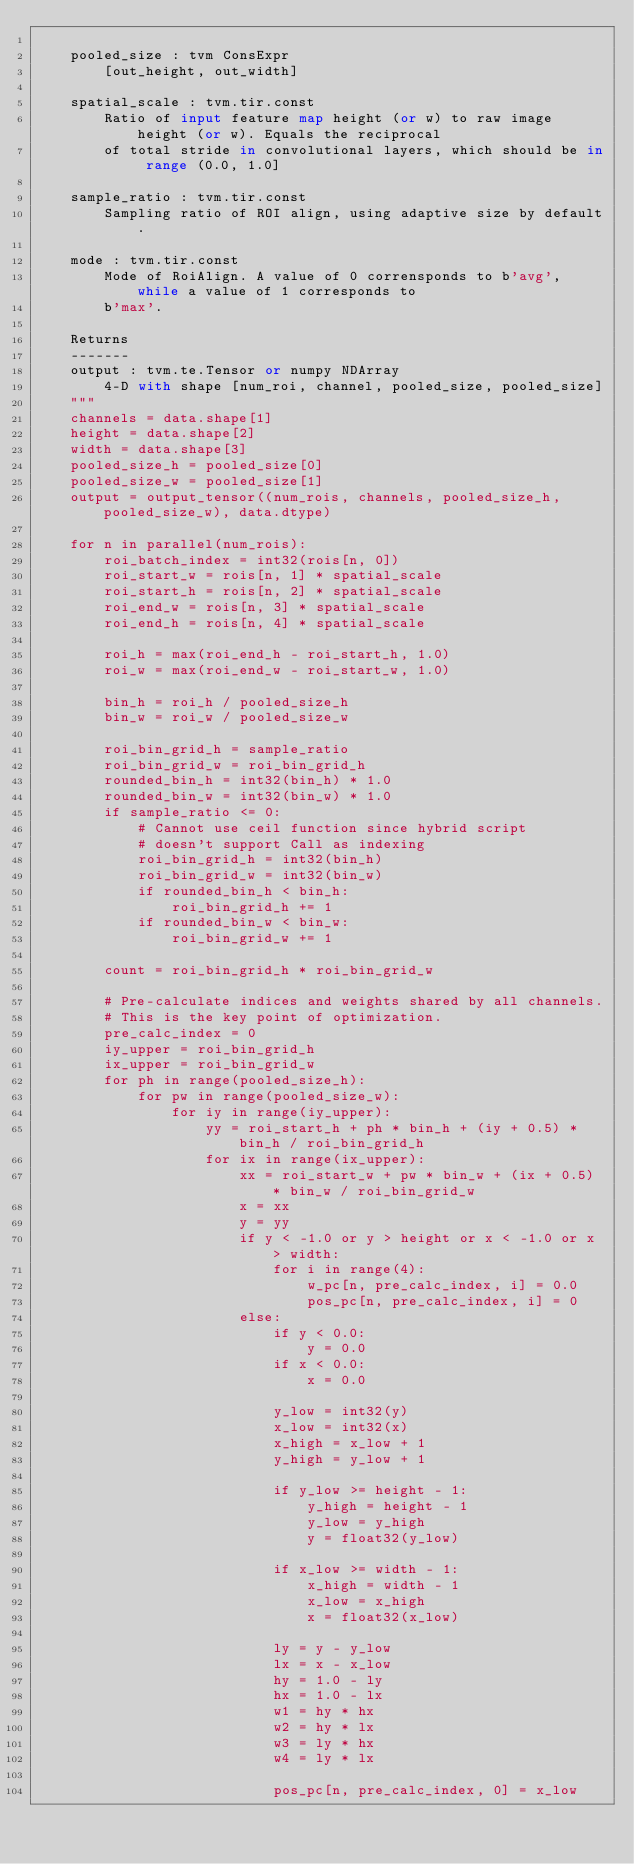<code> <loc_0><loc_0><loc_500><loc_500><_Python_>
    pooled_size : tvm ConsExpr
        [out_height, out_width]

    spatial_scale : tvm.tir.const
        Ratio of input feature map height (or w) to raw image height (or w). Equals the reciprocal
        of total stride in convolutional layers, which should be in range (0.0, 1.0]

    sample_ratio : tvm.tir.const
        Sampling ratio of ROI align, using adaptive size by default.

    mode : tvm.tir.const
        Mode of RoiAlign. A value of 0 corrensponds to b'avg', while a value of 1 corresponds to
        b'max'.

    Returns
    -------
    output : tvm.te.Tensor or numpy NDArray
        4-D with shape [num_roi, channel, pooled_size, pooled_size]
    """
    channels = data.shape[1]
    height = data.shape[2]
    width = data.shape[3]
    pooled_size_h = pooled_size[0]
    pooled_size_w = pooled_size[1]
    output = output_tensor((num_rois, channels, pooled_size_h, pooled_size_w), data.dtype)

    for n in parallel(num_rois):
        roi_batch_index = int32(rois[n, 0])
        roi_start_w = rois[n, 1] * spatial_scale
        roi_start_h = rois[n, 2] * spatial_scale
        roi_end_w = rois[n, 3] * spatial_scale
        roi_end_h = rois[n, 4] * spatial_scale

        roi_h = max(roi_end_h - roi_start_h, 1.0)
        roi_w = max(roi_end_w - roi_start_w, 1.0)

        bin_h = roi_h / pooled_size_h
        bin_w = roi_w / pooled_size_w

        roi_bin_grid_h = sample_ratio
        roi_bin_grid_w = roi_bin_grid_h
        rounded_bin_h = int32(bin_h) * 1.0
        rounded_bin_w = int32(bin_w) * 1.0
        if sample_ratio <= 0:
            # Cannot use ceil function since hybrid script
            # doesn't support Call as indexing
            roi_bin_grid_h = int32(bin_h)
            roi_bin_grid_w = int32(bin_w)
            if rounded_bin_h < bin_h:
                roi_bin_grid_h += 1
            if rounded_bin_w < bin_w:
                roi_bin_grid_w += 1

        count = roi_bin_grid_h * roi_bin_grid_w

        # Pre-calculate indices and weights shared by all channels.
        # This is the key point of optimization.
        pre_calc_index = 0
        iy_upper = roi_bin_grid_h
        ix_upper = roi_bin_grid_w
        for ph in range(pooled_size_h):
            for pw in range(pooled_size_w):
                for iy in range(iy_upper):
                    yy = roi_start_h + ph * bin_h + (iy + 0.5) * bin_h / roi_bin_grid_h
                    for ix in range(ix_upper):
                        xx = roi_start_w + pw * bin_w + (ix + 0.5) * bin_w / roi_bin_grid_w
                        x = xx
                        y = yy
                        if y < -1.0 or y > height or x < -1.0 or x > width:
                            for i in range(4):
                                w_pc[n, pre_calc_index, i] = 0.0
                                pos_pc[n, pre_calc_index, i] = 0
                        else:
                            if y < 0.0:
                                y = 0.0
                            if x < 0.0:
                                x = 0.0

                            y_low = int32(y)
                            x_low = int32(x)
                            x_high = x_low + 1
                            y_high = y_low + 1

                            if y_low >= height - 1:
                                y_high = height - 1
                                y_low = y_high
                                y = float32(y_low)

                            if x_low >= width - 1:
                                x_high = width - 1
                                x_low = x_high
                                x = float32(x_low)

                            ly = y - y_low
                            lx = x - x_low
                            hy = 1.0 - ly
                            hx = 1.0 - lx
                            w1 = hy * hx
                            w2 = hy * lx
                            w3 = ly * hx
                            w4 = ly * lx

                            pos_pc[n, pre_calc_index, 0] = x_low</code> 